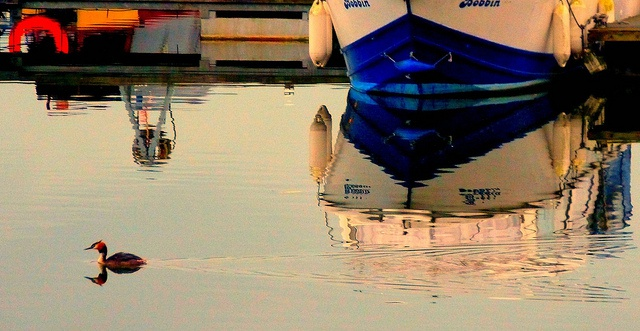Describe the objects in this image and their specific colors. I can see boat in black, tan, and navy tones and bird in black, maroon, and tan tones in this image. 